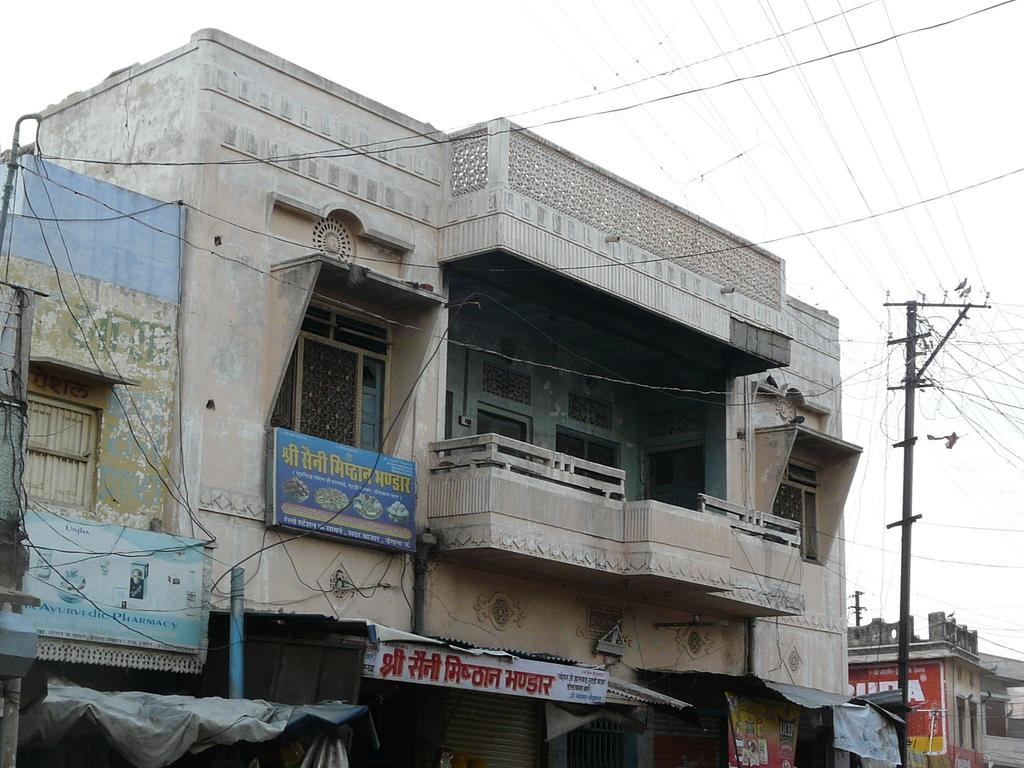What type of structure is visible in the image? There is a building with windows in the image. What is located beneath the building? There are shops under the building. What can be seen attached to the building in the image? There is an electric pole with wires in the image. Are there any other buildings or houses nearby? Yes, there are other houses beside the building. What is visible in the background of the image? The sky is visible in the image. Can you see any fangs on the building in the image? There are no fangs present on the building in the image. What type of flower is growing on the electric pole in the image? There are no flowers present on the electric pole in the image. 